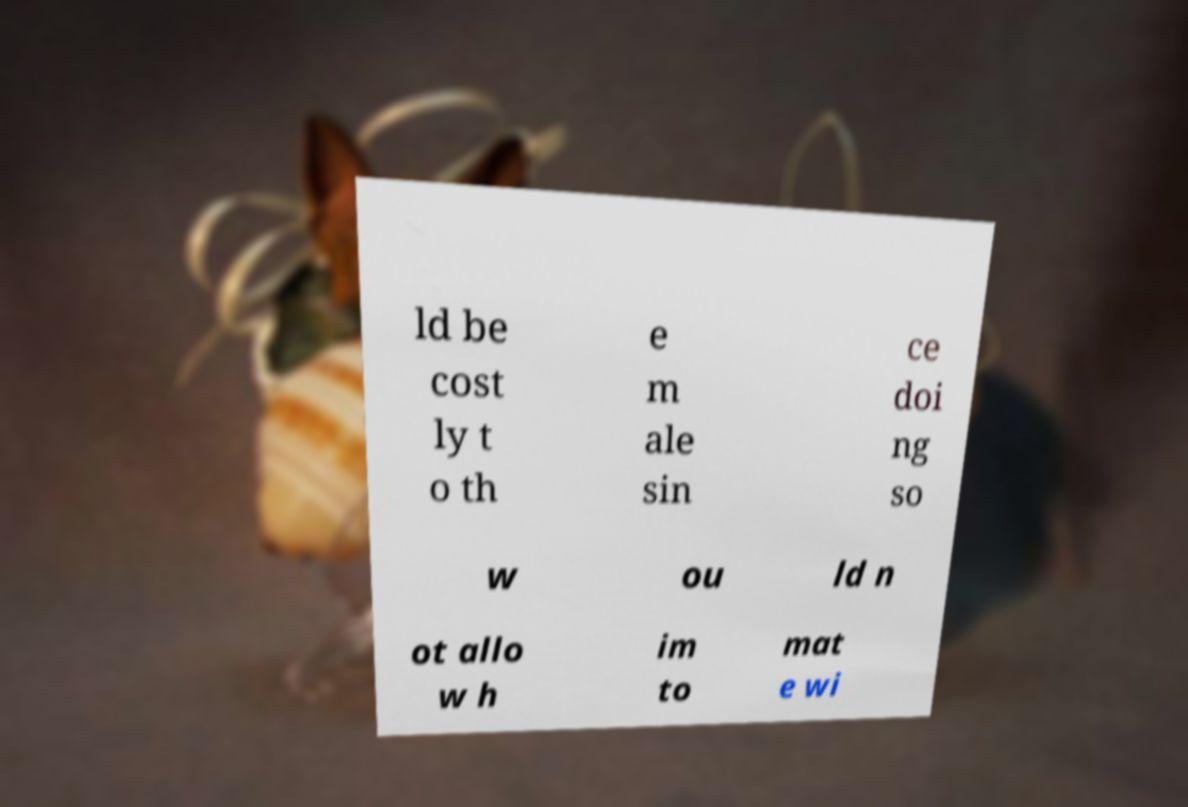Can you read and provide the text displayed in the image?This photo seems to have some interesting text. Can you extract and type it out for me? ld be cost ly t o th e m ale sin ce doi ng so w ou ld n ot allo w h im to mat e wi 